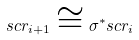<formula> <loc_0><loc_0><loc_500><loc_500>\L s c r _ { i + 1 } \cong \sigma ^ { \ast } \L s c r _ { i }</formula> 